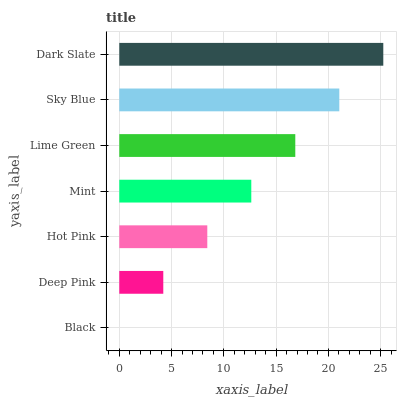Is Black the minimum?
Answer yes or no. Yes. Is Dark Slate the maximum?
Answer yes or no. Yes. Is Deep Pink the minimum?
Answer yes or no. No. Is Deep Pink the maximum?
Answer yes or no. No. Is Deep Pink greater than Black?
Answer yes or no. Yes. Is Black less than Deep Pink?
Answer yes or no. Yes. Is Black greater than Deep Pink?
Answer yes or no. No. Is Deep Pink less than Black?
Answer yes or no. No. Is Mint the high median?
Answer yes or no. Yes. Is Mint the low median?
Answer yes or no. Yes. Is Dark Slate the high median?
Answer yes or no. No. Is Deep Pink the low median?
Answer yes or no. No. 